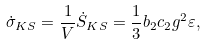<formula> <loc_0><loc_0><loc_500><loc_500>\dot { \sigma } _ { K S } = { \frac { 1 } { V } } \dot { S } _ { K S } = { \frac { 1 } { 3 } } b _ { 2 } c _ { 2 } g ^ { 2 } \varepsilon ,</formula> 